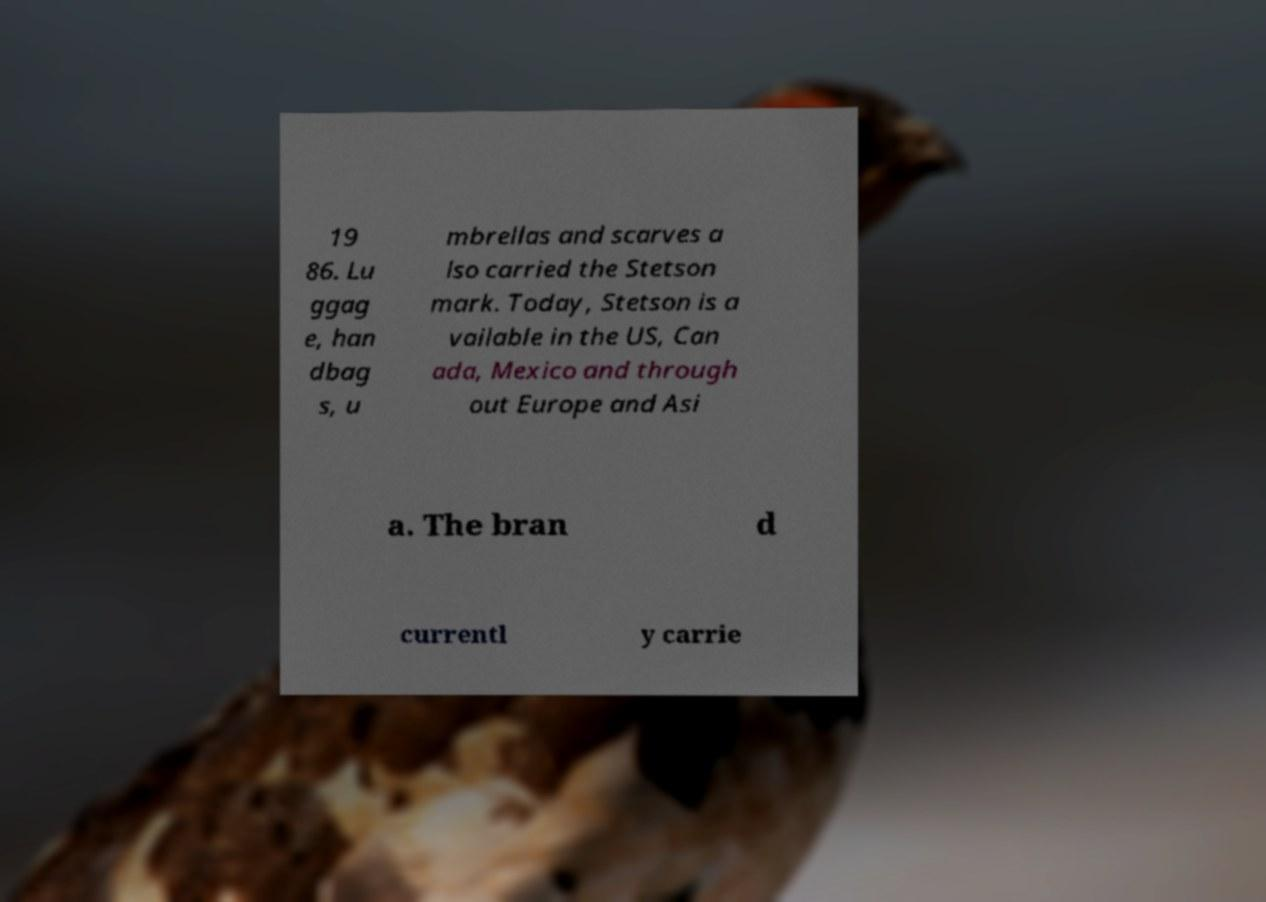What messages or text are displayed in this image? I need them in a readable, typed format. 19 86. Lu ggag e, han dbag s, u mbrellas and scarves a lso carried the Stetson mark. Today, Stetson is a vailable in the US, Can ada, Mexico and through out Europe and Asi a. The bran d currentl y carrie 